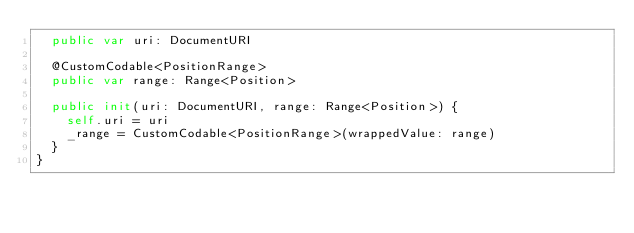Convert code to text. <code><loc_0><loc_0><loc_500><loc_500><_Swift_>  public var uri: DocumentURI

  @CustomCodable<PositionRange>
  public var range: Range<Position>

  public init(uri: DocumentURI, range: Range<Position>) {
    self.uri = uri
    _range = CustomCodable<PositionRange>(wrappedValue: range)
  }
}
</code> 